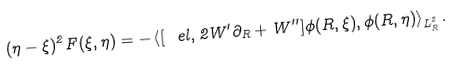<formula> <loc_0><loc_0><loc_500><loc_500>( \eta - \xi ) ^ { 2 } F ( \xi , \eta ) = - \left < [ \ e l , 2 W ^ { \prime } \partial _ { R } + W ^ { \prime \prime } ] \phi ( R , \xi ) , \phi ( R , \eta ) \right > _ { L _ { R } ^ { 2 } } .</formula> 